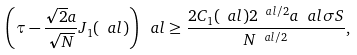Convert formula to latex. <formula><loc_0><loc_0><loc_500><loc_500>\left ( \tau - \frac { \sqrt { 2 } a } { \sqrt { N } } J _ { 1 } ( \ a l ) \right ) ^ { \ } a l \geq \frac { 2 C _ { 1 } ( \ a l ) 2 ^ { \ a l / 2 } a ^ { \ } a l \sigma S } { N ^ { \ a l / 2 } } ,</formula> 